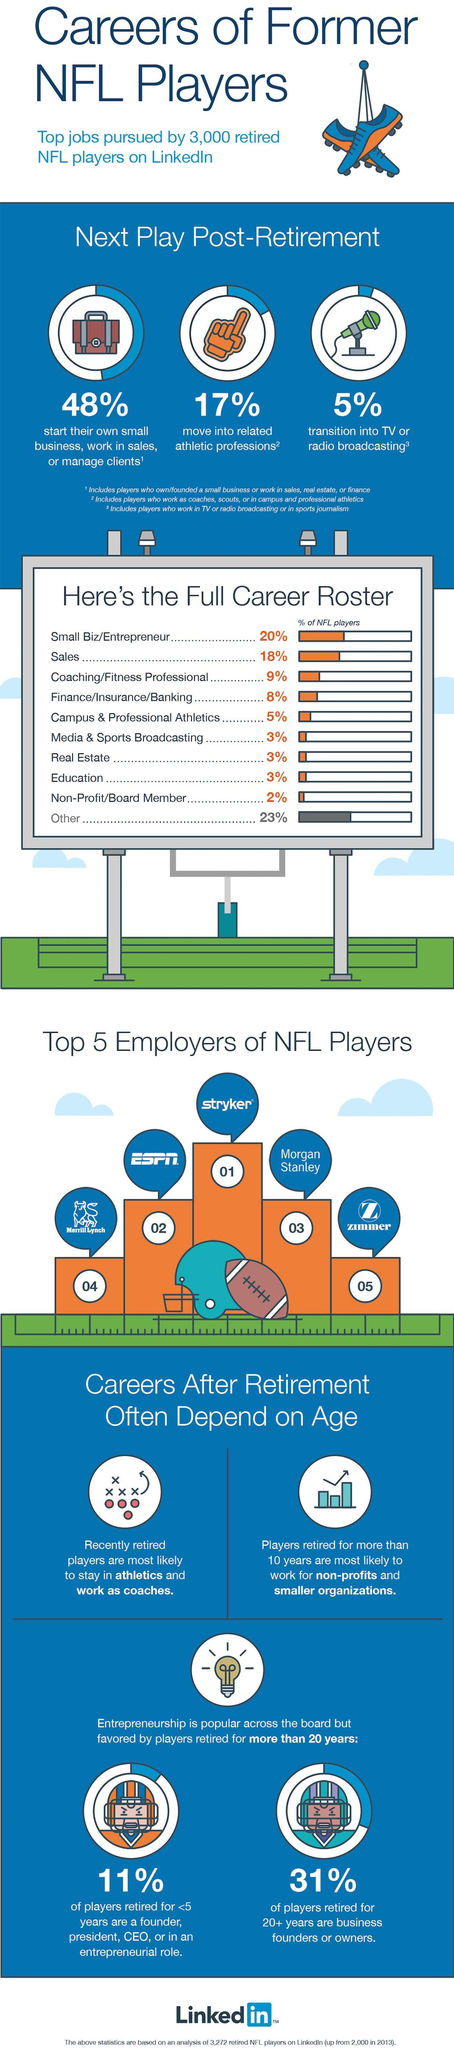Indicate a few pertinent items in this graphic. According to a recent study, a significant percentage of NFL players, after retiring from their sport, choose to start their own small businesses, work in sales, or manage clients. Specifically, 48% of NFL players pursue these opportunities. In post-retirement, a significant percentage of NFL players transition into related athletic professions, with 17% finding success in these fields. In a recent study of retired NFL players who played for 20 or more years, it was found that 31% of them went on to become business founders or owners. According to a recent study, only 3% of NFL players transition into media and sports broadcasting after retiring from the sport. 